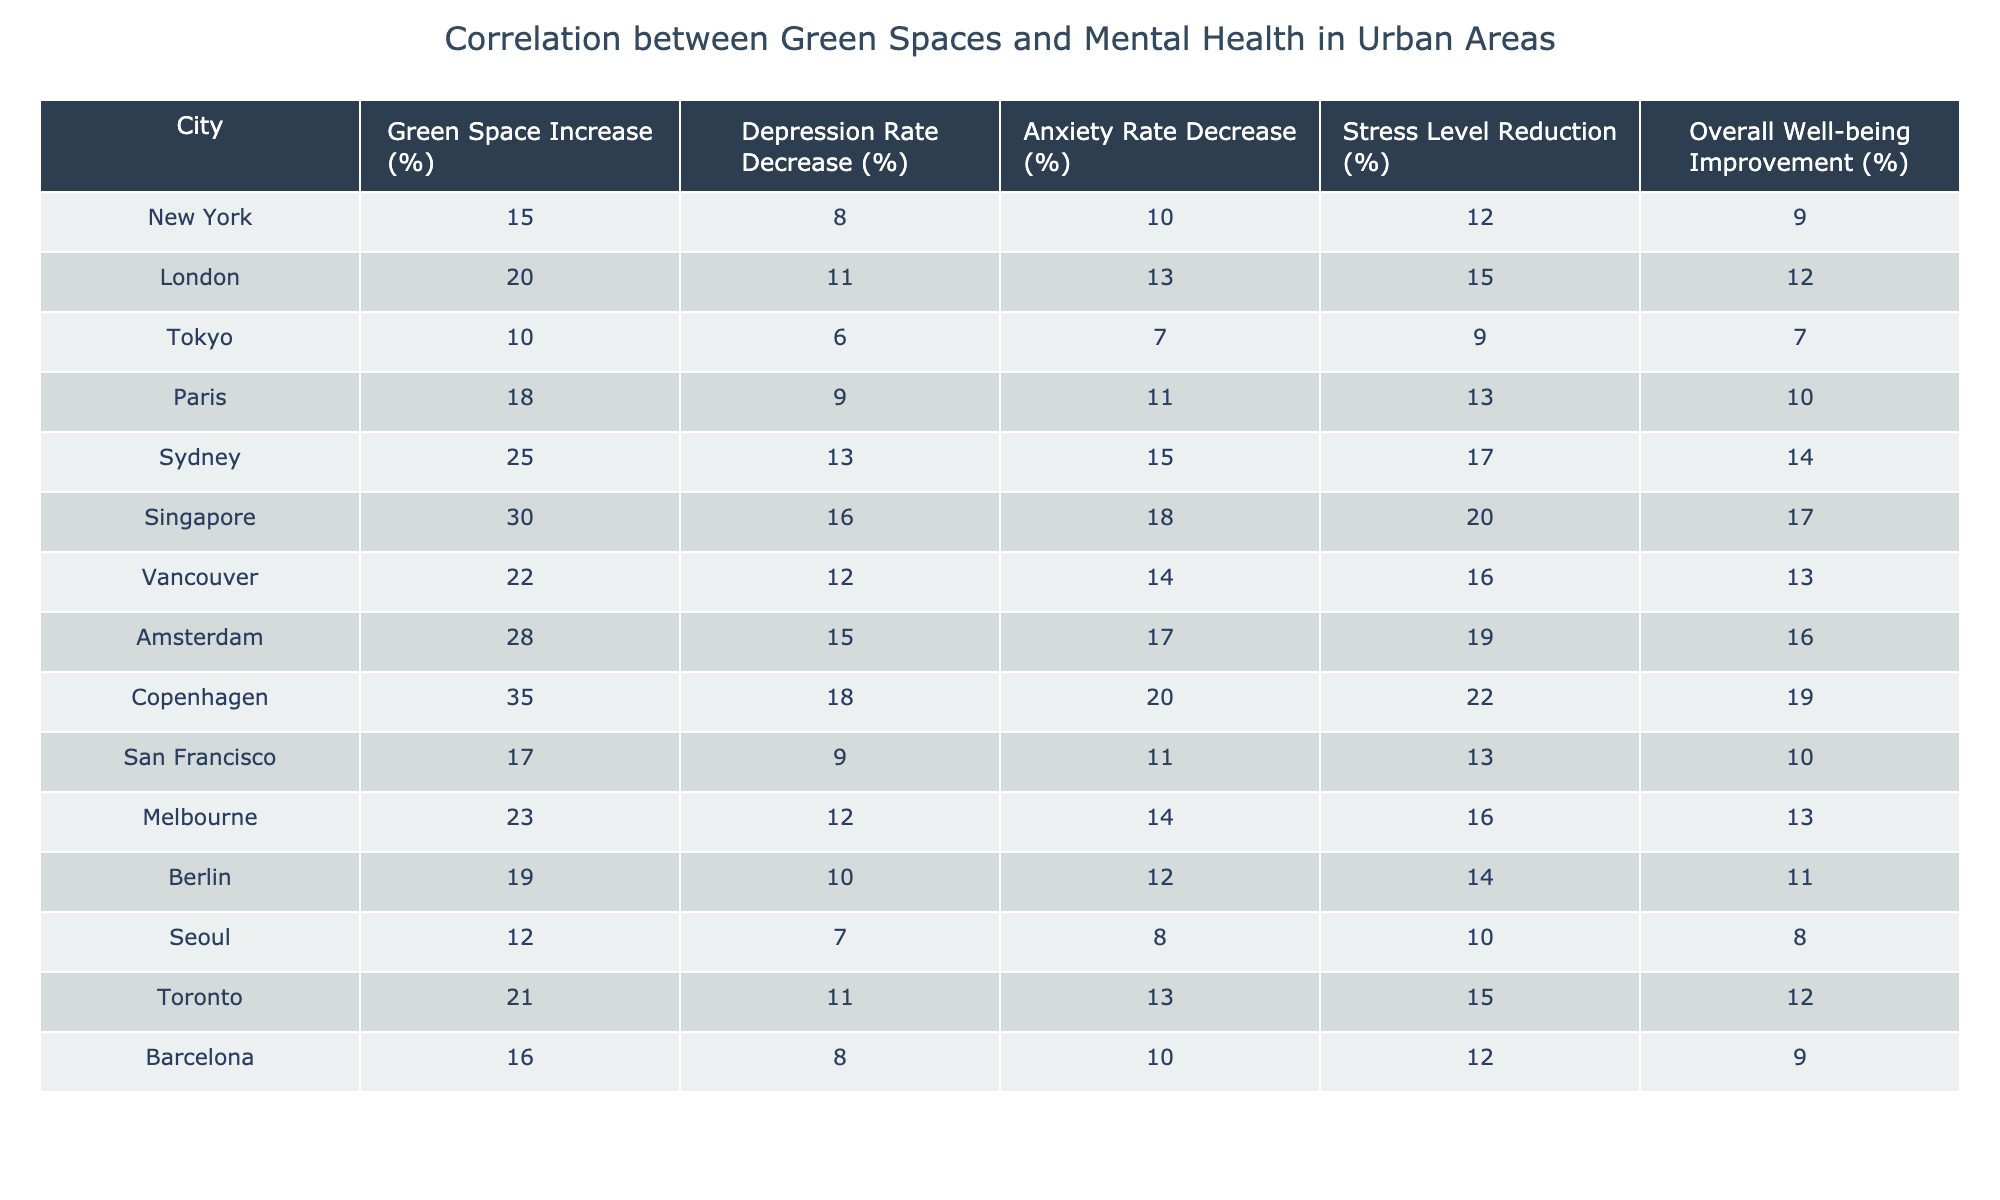What is the city with the highest increase in green space? By examining the "Green Space Increase (%)" column, we see that Copenhagen has the highest percentage at 35%.
Answer: Copenhagen What is the mental health improvement percentage for Sydney? In the "Overall Well-being Improvement (%)" column, Sydney has a value of 14%.
Answer: 14% Which city shows a decrease in depression rates equal to the increase in its green space (in percentage)? The city with a depression rate decrease equal to its green space increase is San Francisco, which has both values at 17%.
Answer: No city matches this criterion What is the average decrease in anxiety rates across all cities? By summing the "Anxiety Rate Decrease (%)" values (10 + 13 + 7 + 11 + 15 + 18 + 14 + 17 + 20 + 11 + 14 + 12 + 8 + 13 + 10 = 217) and dividing by the number of cities (15), the average is 217/15 = 14.47%.
Answer: 14.47% Is there a city where the reduction in stress levels is greater than the overall well-being improvement? By comparing the "Stress Level Reduction (%)" and "Overall Well-being Improvement (%)" for each city, we observe that there is a case: Tokyo shows stress reduction (9%) that is greater than overall improvement (7%), so the answer is Yes.
Answer: Yes Which two cities have the closest percentage differences between their depression rate decrease and overall well-being improvement? By checking the difference between "Depression Rate Decrease (%)" and "Overall Well-being Improvement (%)" for each city, we find Berlin (10% vs. 11%, difference of 1%) and Amsterdam (15% vs. 16%, difference of 1%) have the closest percentages with a difference of 1%.
Answer: Berlin and Amsterdam What is the total percentage of depression rate decrease for the top three cities with the highest green space increase? The top three cities with the highest green space increase are Copenhagen (18%), Singapore (16%), and Sydney (13%). The total depression rate decrease is 18% + 16% + 13% = 47%.
Answer: 47% Which city has a higher reduction in stress levels compared to anxiety levels? By comparing the "Stress Level Reduction (%)" and "Anxiety Rate Decrease (%)", Sydney shows 17% in stress reduction vs. 15% in anxiety decrease, making it the only city.
Answer: Sydney If New York were to increase its green space by 10% more, what would be the new overall well-being improvement percentage? New York currently has an overall well-being improvement of 9%. Assuming the overall well-being improvement increases in proportion to green space (15% increase), we can assume growth: 9% + 10% = 19%.
Answer: 19% What is the difference in overall well-being improvement between the city with the highest and lowest values? The city with the highest overall well-being improvement is Copenhagen (19%) and the lowest is Tokyo (7%). The difference is 19% - 7% = 12%.
Answer: 12% 